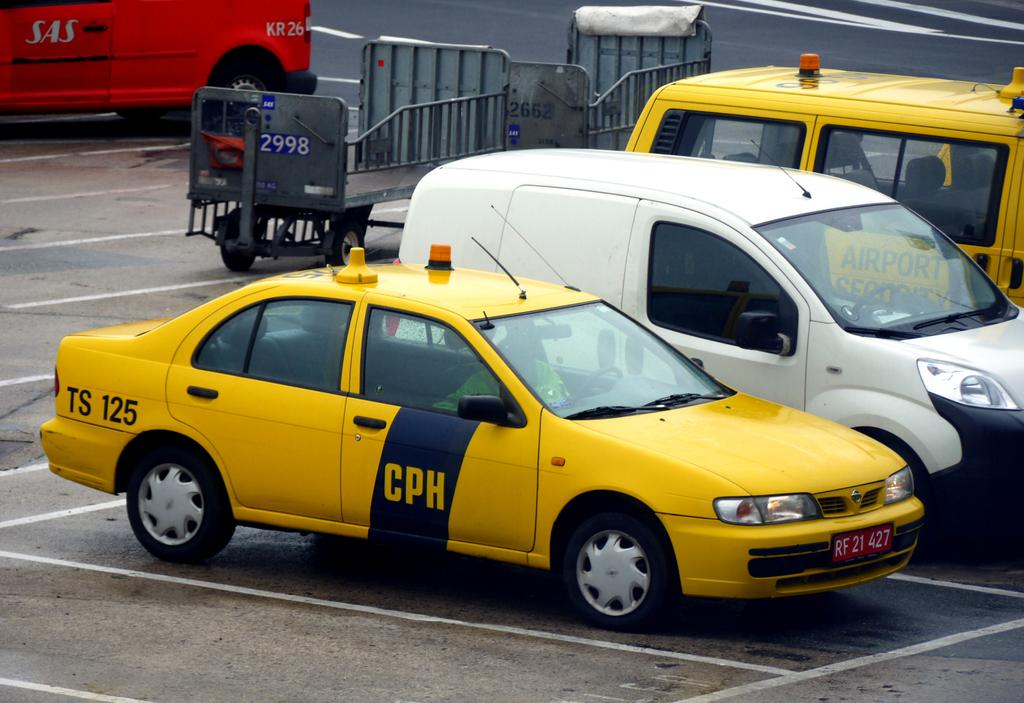Provide a one-sentence caption for the provided image. A yellow CPH car is parked by a white van. 